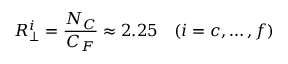Convert formula to latex. <formula><loc_0><loc_0><loc_500><loc_500>R _ { \perp } ^ { i } = \frac { N _ { C } } { C _ { F } } \approx 2 . 2 5 \quad ( i = c , \dots , f )</formula> 